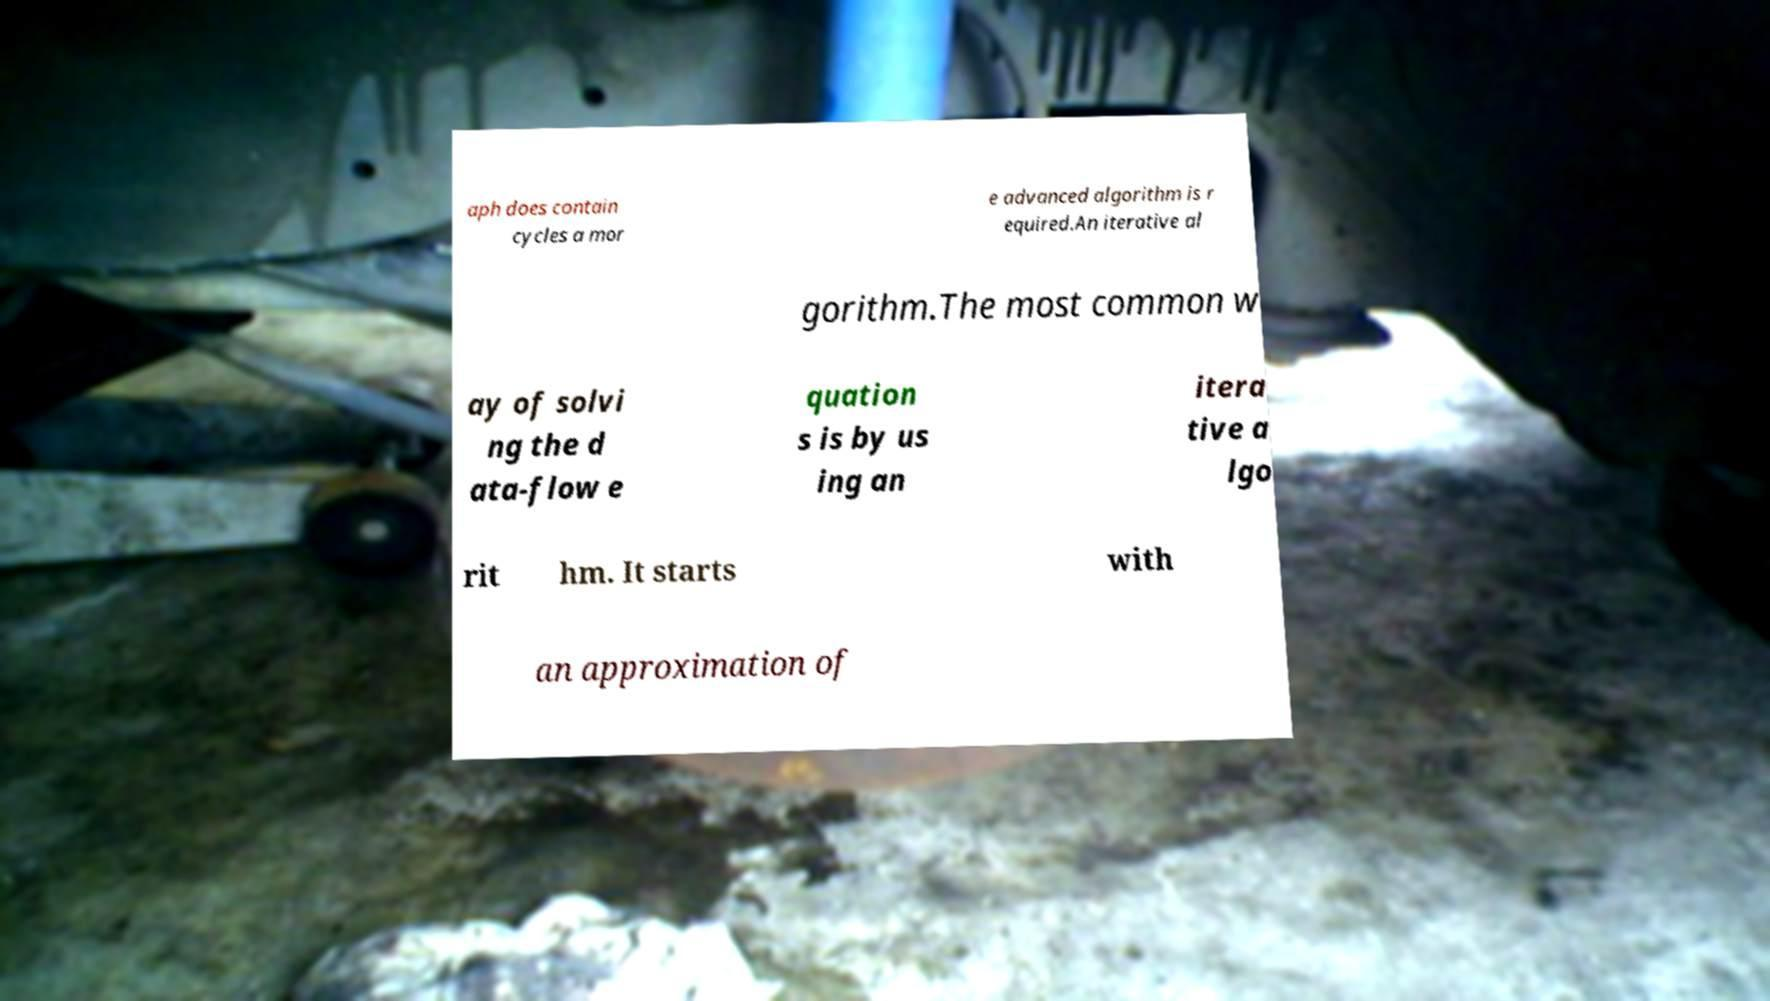Can you read and provide the text displayed in the image?This photo seems to have some interesting text. Can you extract and type it out for me? aph does contain cycles a mor e advanced algorithm is r equired.An iterative al gorithm.The most common w ay of solvi ng the d ata-flow e quation s is by us ing an itera tive a lgo rit hm. It starts with an approximation of 